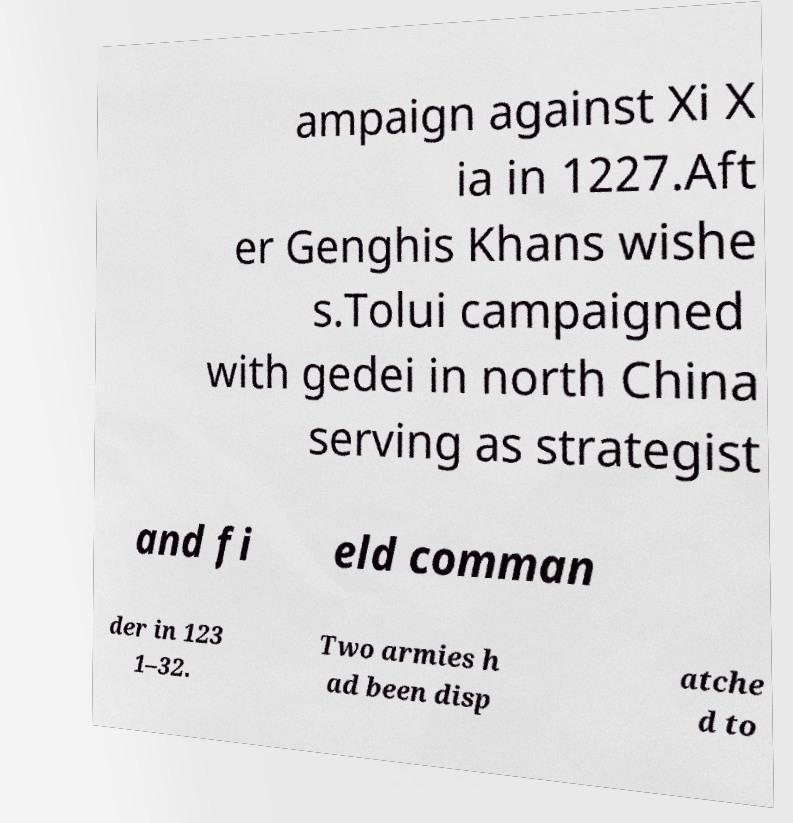For documentation purposes, I need the text within this image transcribed. Could you provide that? ampaign against Xi X ia in 1227.Aft er Genghis Khans wishe s.Tolui campaigned with gedei in north China serving as strategist and fi eld comman der in 123 1–32. Two armies h ad been disp atche d to 